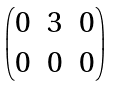<formula> <loc_0><loc_0><loc_500><loc_500>\begin{pmatrix} 0 & 3 & 0 \\ 0 & 0 & 0 \end{pmatrix}</formula> 